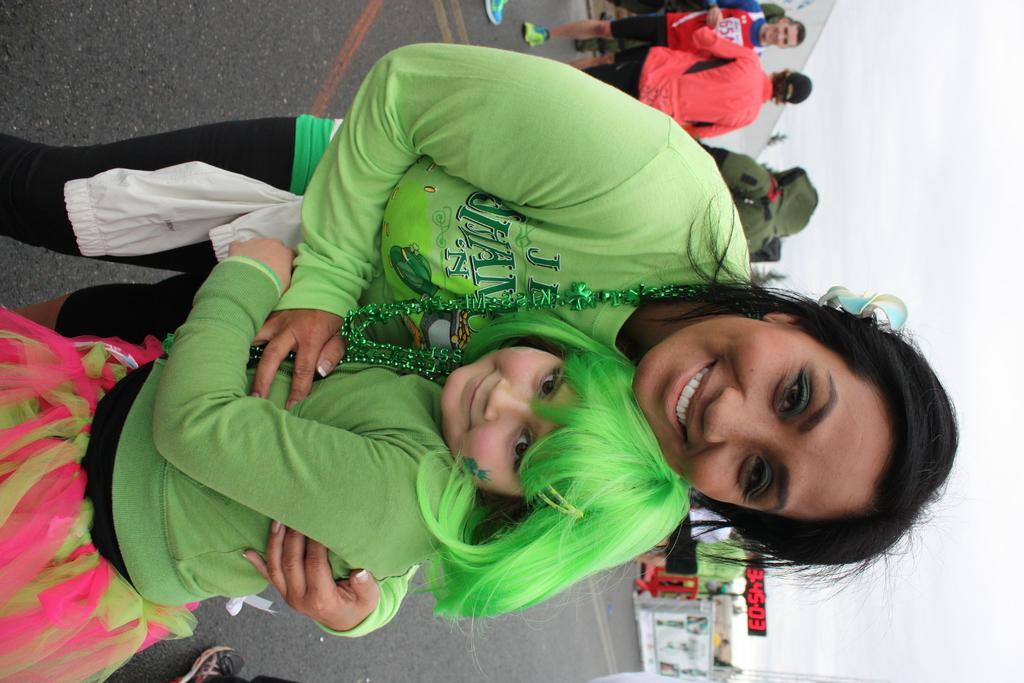Can you describe this image briefly? In the foreground of this image, there is a woman and a girl in green color dress standing on the ground. In the background, there are few persons, building, trees, a timer board and the sky. 